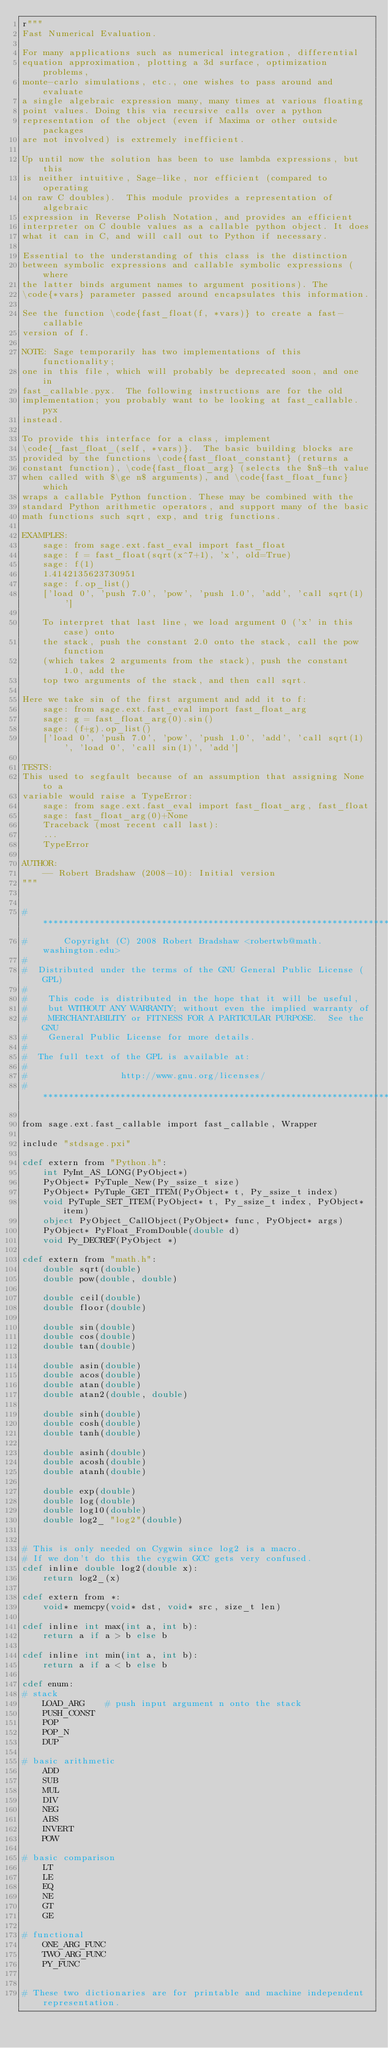Convert code to text. <code><loc_0><loc_0><loc_500><loc_500><_Cython_>r"""
Fast Numerical Evaluation.

For many applications such as numerical integration, differential
equation approximation, plotting a 3d surface, optimization problems,
monte-carlo simulations, etc., one wishes to pass around and evaluate
a single algebraic expression many, many times at various floating
point values. Doing this via recursive calls over a python
representation of the object (even if Maxima or other outside packages
are not involved) is extremely inefficient.

Up until now the solution has been to use lambda expressions, but this
is neither intuitive, Sage-like, nor efficient (compared to operating
on raw C doubles).  This module provides a representation of algebraic
expression in Reverse Polish Notation, and provides an efficient
interpreter on C double values as a callable python object. It does
what it can in C, and will call out to Python if necessary.

Essential to the understanding of this class is the distinction
between symbolic expressions and callable symbolic expressions (where
the latter binds argument names to argument positions). The
\code{*vars} parameter passed around encapsulates this information.

See the function \code{fast_float(f, *vars)} to create a fast-callable
version of f.

NOTE: Sage temporarily has two implementations of this functionality;
one in this file, which will probably be deprecated soon, and one in
fast_callable.pyx.  The following instructions are for the old
implementation; you probably want to be looking at fast_callable.pyx
instead.

To provide this interface for a class, implement
\code{_fast_float_(self, *vars)}.  The basic building blocks are
provided by the functions \code{fast_float_constant} (returns a
constant function), \code{fast_float_arg} (selects the $n$-th value
when called with $\ge n$ arguments), and \code{fast_float_func} which
wraps a callable Python function. These may be combined with the
standard Python arithmetic operators, and support many of the basic
math functions such sqrt, exp, and trig functions.

EXAMPLES:
    sage: from sage.ext.fast_eval import fast_float
    sage: f = fast_float(sqrt(x^7+1), 'x', old=True)
    sage: f(1)
    1.4142135623730951
    sage: f.op_list()
    ['load 0', 'push 7.0', 'pow', 'push 1.0', 'add', 'call sqrt(1)']

    To interpret that last line, we load argument 0 ('x' in this case) onto
    the stack, push the constant 2.0 onto the stack, call the pow function
    (which takes 2 arguments from the stack), push the constant 1.0, add the
    top two arguments of the stack, and then call sqrt.

Here we take sin of the first argument and add it to f:
    sage: from sage.ext.fast_eval import fast_float_arg
    sage: g = fast_float_arg(0).sin()
    sage: (f+g).op_list()
    ['load 0', 'push 7.0', 'pow', 'push 1.0', 'add', 'call sqrt(1)', 'load 0', 'call sin(1)', 'add']

TESTS:
This used to segfault because of an assumption that assigning None to a
variable would raise a TypeError:
    sage: from sage.ext.fast_eval import fast_float_arg, fast_float
    sage: fast_float_arg(0)+None
    Traceback (most recent call last):
    ...
    TypeError

AUTHOR:
    -- Robert Bradshaw (2008-10): Initial version
"""


#*****************************************************************************
#       Copyright (C) 2008 Robert Bradshaw <robertwb@math.washington.edu>
#
#  Distributed under the terms of the GNU General Public License (GPL)
#
#    This code is distributed in the hope that it will be useful,
#    but WITHOUT ANY WARRANTY; without even the implied warranty of
#    MERCHANTABILITY or FITNESS FOR A PARTICULAR PURPOSE.  See the GNU
#    General Public License for more details.
#
#  The full text of the GPL is available at:
#
#                  http://www.gnu.org/licenses/
#*****************************************************************************

from sage.ext.fast_callable import fast_callable, Wrapper

include "stdsage.pxi"

cdef extern from "Python.h":
    int PyInt_AS_LONG(PyObject*)
    PyObject* PyTuple_New(Py_ssize_t size)
    PyObject* PyTuple_GET_ITEM(PyObject* t, Py_ssize_t index)
    void PyTuple_SET_ITEM(PyObject* t, Py_ssize_t index, PyObject* item)
    object PyObject_CallObject(PyObject* func, PyObject* args)
    PyObject* PyFloat_FromDouble(double d)
    void Py_DECREF(PyObject *)

cdef extern from "math.h":
    double sqrt(double)
    double pow(double, double)

    double ceil(double)
    double floor(double)

    double sin(double)
    double cos(double)
    double tan(double)

    double asin(double)
    double acos(double)
    double atan(double)
    double atan2(double, double)

    double sinh(double)
    double cosh(double)
    double tanh(double)

    double asinh(double)
    double acosh(double)
    double atanh(double)

    double exp(double)
    double log(double)
    double log10(double)
    double log2_ "log2"(double)


# This is only needed on Cygwin since log2 is a macro.
# If we don't do this the cygwin GCC gets very confused.
cdef inline double log2(double x):
    return log2_(x)

cdef extern from *:
    void* memcpy(void* dst, void* src, size_t len)

cdef inline int max(int a, int b):
    return a if a > b else b

cdef inline int min(int a, int b):
    return a if a < b else b

cdef enum:
# stack
    LOAD_ARG    # push input argument n onto the stack
    PUSH_CONST
    POP
    POP_N
    DUP

# basic arithmetic
    ADD
    SUB
    MUL
    DIV
    NEG
    ABS
    INVERT
    POW

# basic comparison
    LT
    LE
    EQ
    NE
    GT
    GE

# functional
    ONE_ARG_FUNC
    TWO_ARG_FUNC
    PY_FUNC


# These two dictionaries are for printable and machine independent representation.
</code> 